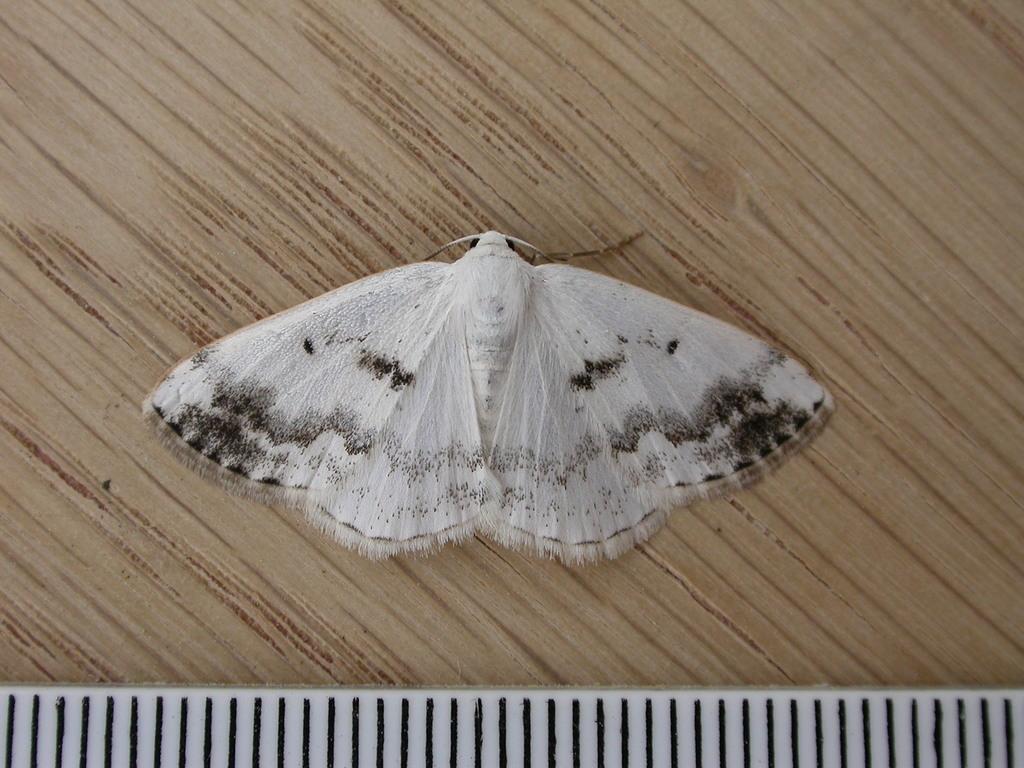How would you summarize this image in a sentence or two? In this image, we can see a butterfly on the wooden surface. 